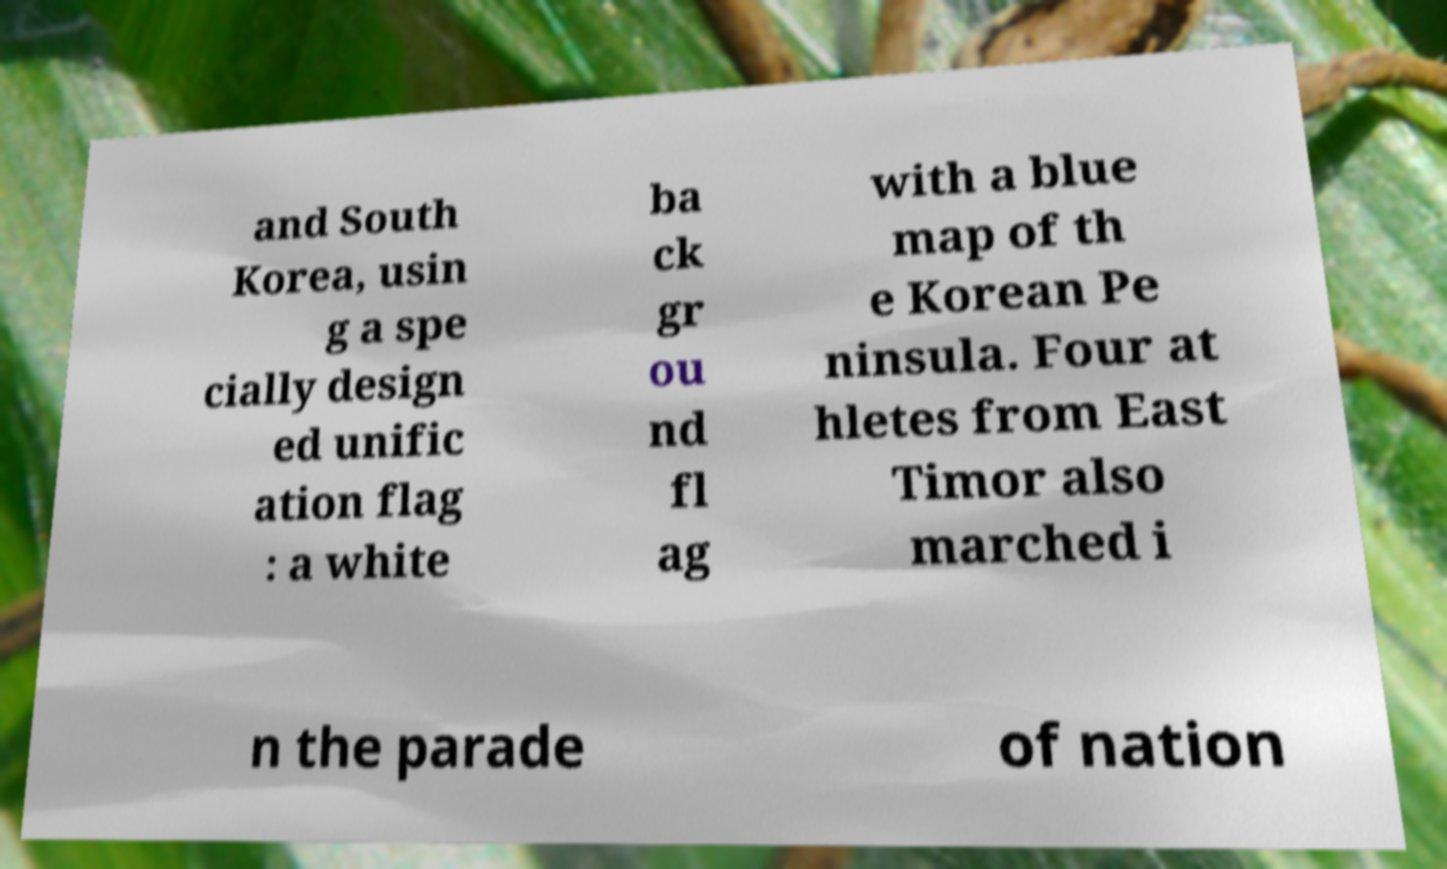Could you assist in decoding the text presented in this image and type it out clearly? and South Korea, usin g a spe cially design ed unific ation flag : a white ba ck gr ou nd fl ag with a blue map of th e Korean Pe ninsula. Four at hletes from East Timor also marched i n the parade of nation 